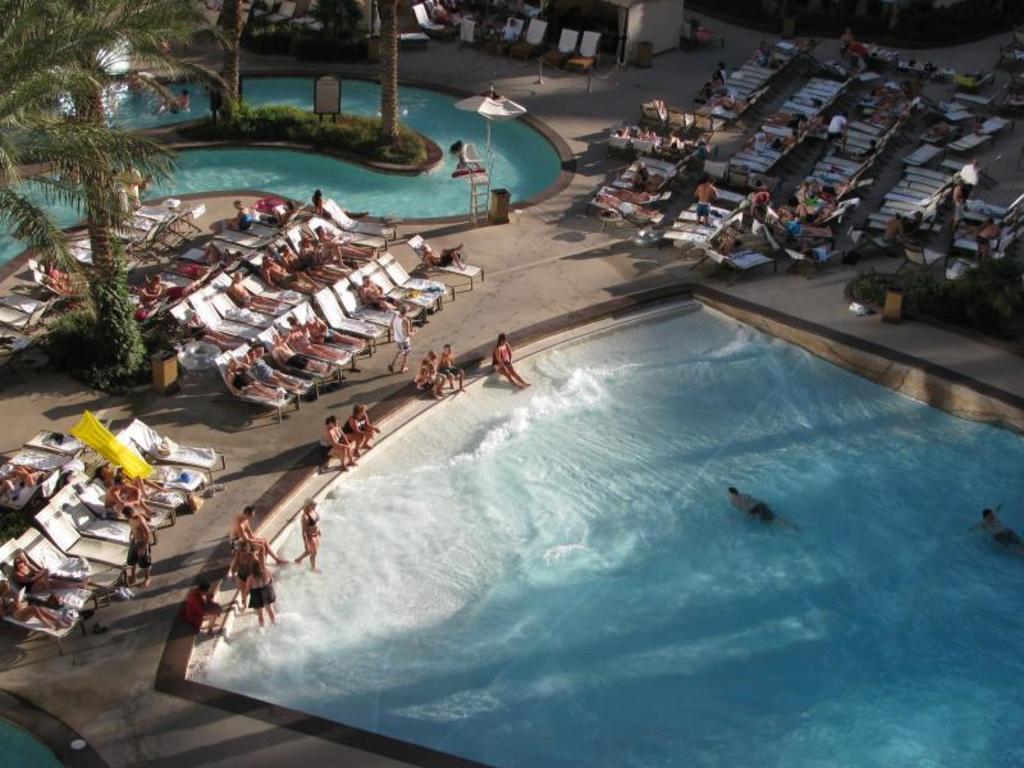In one or two sentences, can you explain what this image depicts? In this image there is a swimming pool on the right side in which there are few people swimming in it. Beside the swimming pool there are chairs on which there are few people sleeping on it. On the left side there is another swimming pool in which there are trees in the garden which is in the middle of the pool. On the left side there is a tree, around which there are chairs. 